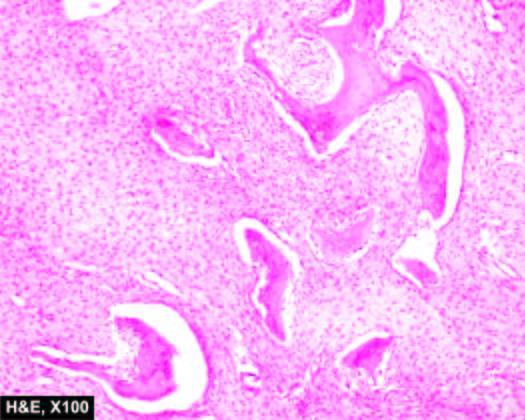re circle shown with yellow-orange line characteristically absent?
Answer the question using a single word or phrase. No 